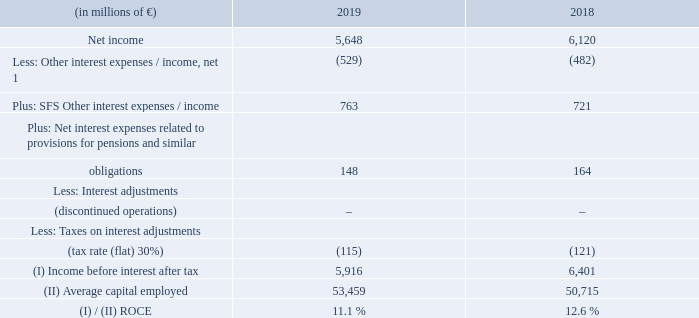A.2.6 Calculation of return on capital employed
For purposes of calculating ROCE in interim periods, income before interest after tax is annualized. Average capital employed is determined using the average of the respective balances as of the quarterly reporting dates for the periods under review.
[1] Item Other interest expenses / income, net primarily consists of interest relating to corporate debt, and related hedging activities, as well as interest income on corporate assets.
How is the Average capital employed is determined ? Using the average of the respective balances as of the quarterly reporting dates for the periods under review. What does Item Other interest expenses / income consist of? Net primarily consists of interest relating to corporate debt, and related hedging activities, as well as interest income on corporate assets. What is the income tax rate for 2019? 30%. What is the average net income for the 2 years?
Answer scale should be: million. (5,648 + 6,120) / 2
Answer: 5884. What is the increase / (decrease) in income tax from 2018 to 2019?
Answer scale should be: percent. -115 / -121 - 1
Answer: -4.96. What is the increase / (decrease) in Average capital employed from 2018 to 2019?
Answer scale should be: million. 53,459 - 50,715
Answer: 2744. 